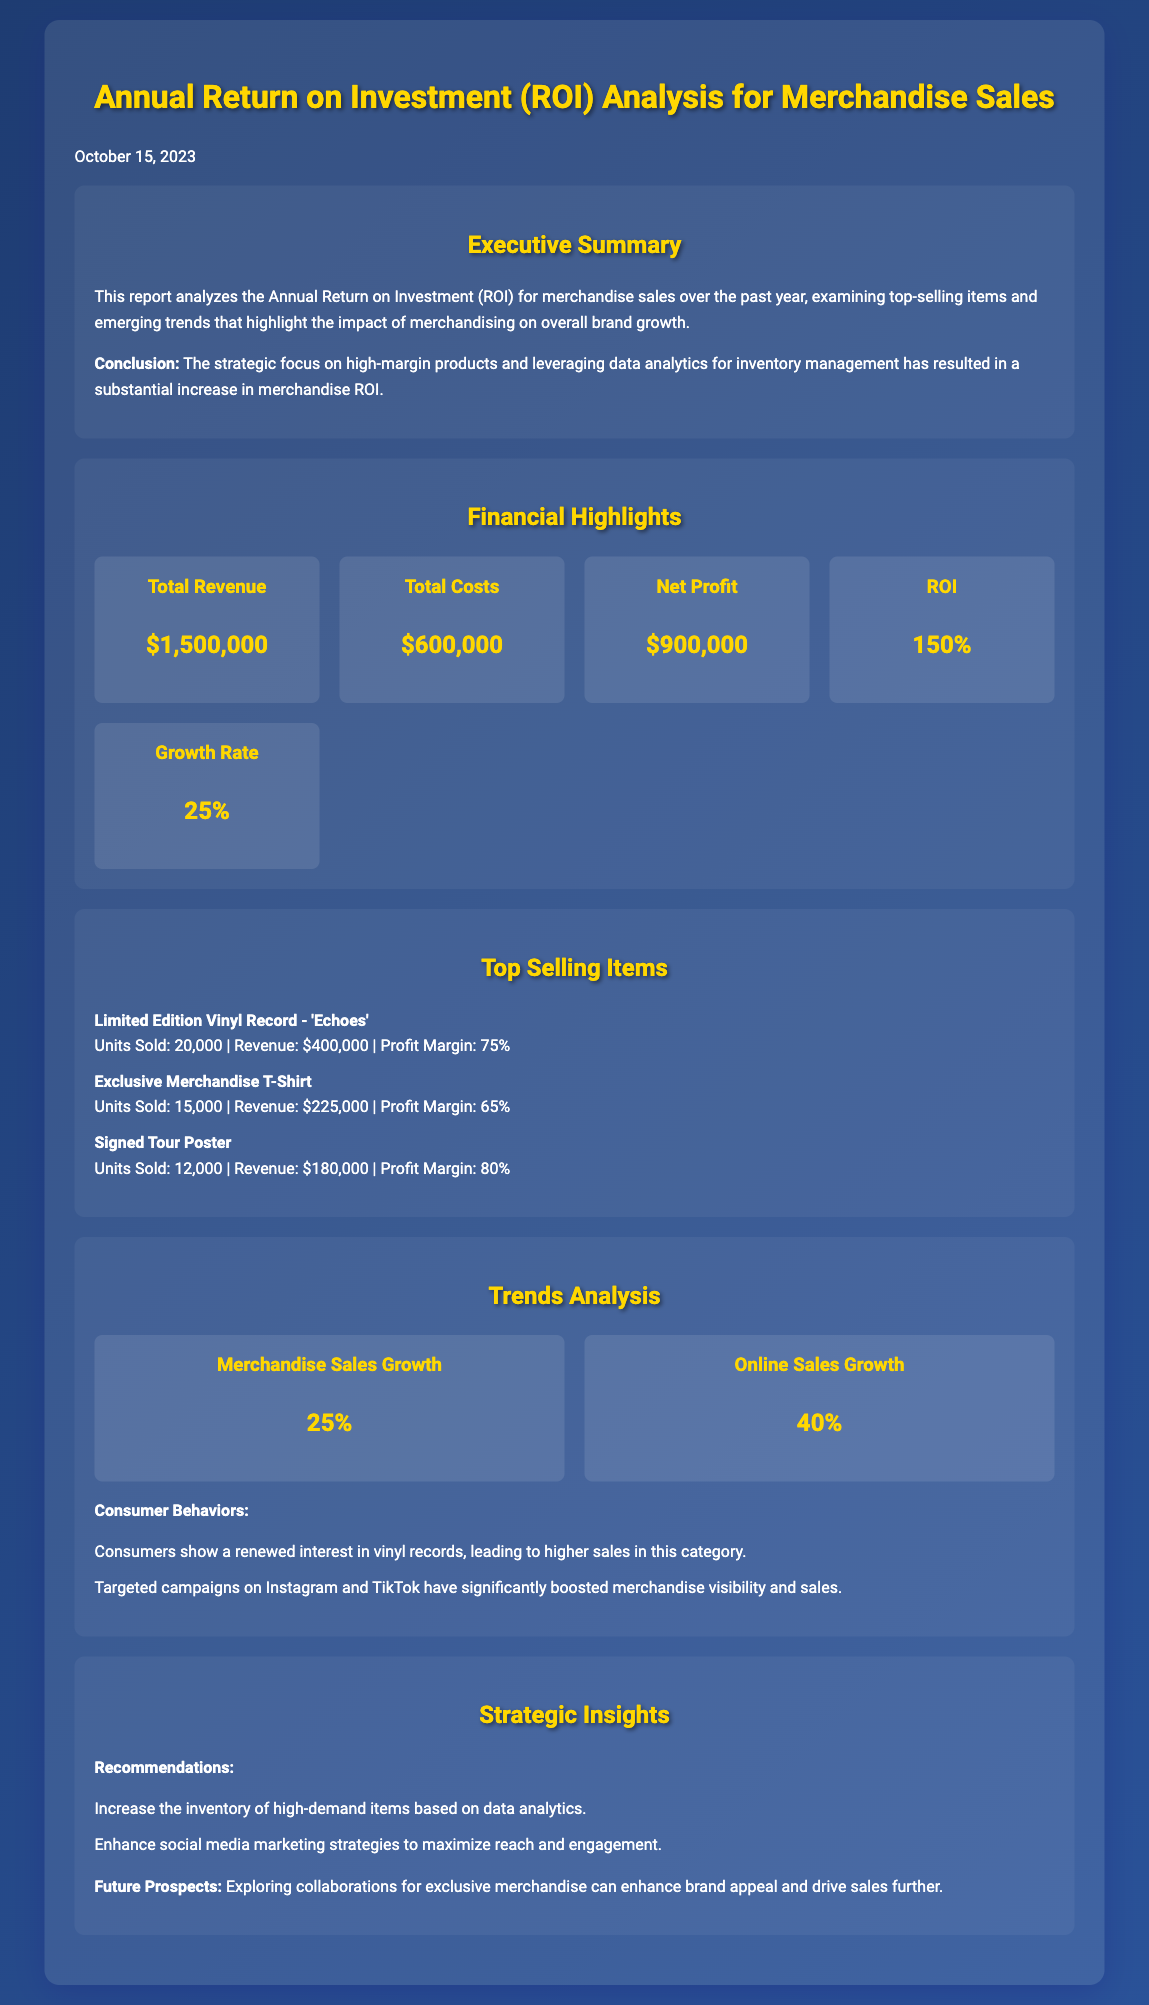What is the total revenue? The total revenue is presented in the highlights section of the document, which indicates $1,500,000.
Answer: $1,500,000 What is the net profit? The net profit is stated in the financial highlights section, amounting to $900,000.
Answer: $900,000 What is the ROI percentage? The ROI percentage can be found in the financial highlights, listed as 150%.
Answer: 150% Which item generated the highest revenue? The limited edition vinyl record 'Echoes' is noted for generating the highest revenue of $400,000 among the top-selling items.
Answer: Limited Edition Vinyl Record - 'Echoes' What was the growth rate of merchandise sales? The merchandise sales growth is highlighted in the trends section, which is reported as 25%.
Answer: 25% What marketing strategies improved sales visibility? The document mentions targeted campaigns on Instagram and TikTok as effective strategies for boosting merchandise visibility.
Answer: Instagram and TikTok What is the total cost incurred? The total cost can be found among the financial highlights in the document, which is $600,000.
Answer: $600,000 How many units of the Exclusive Merchandise T-Shirt were sold? The number of units sold for the Exclusive Merchandise T-Shirt is listed as 15,000 in the top-selling items section.
Answer: 15,000 What is a recommended strategy to maximize merchandise sales? One recommendation in the strategic insights is to enhance social media marketing strategies for maximizing reach and engagement.
Answer: Enhance social media marketing strategies 